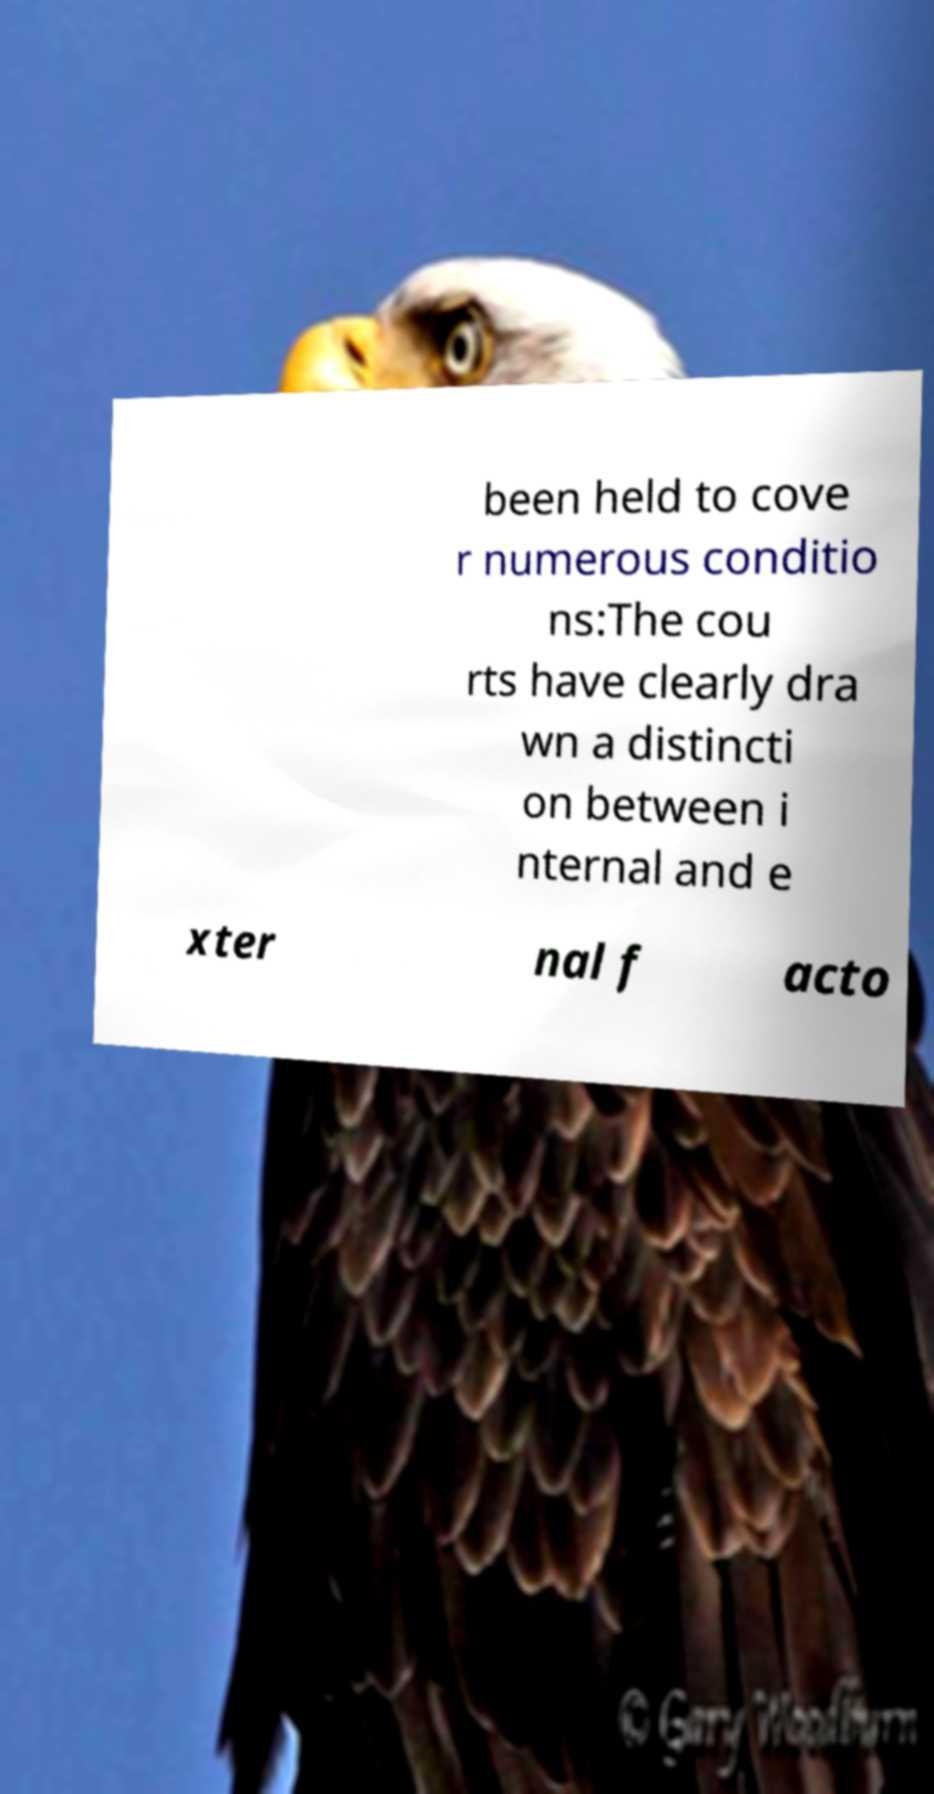There's text embedded in this image that I need extracted. Can you transcribe it verbatim? been held to cove r numerous conditio ns:The cou rts have clearly dra wn a distincti on between i nternal and e xter nal f acto 